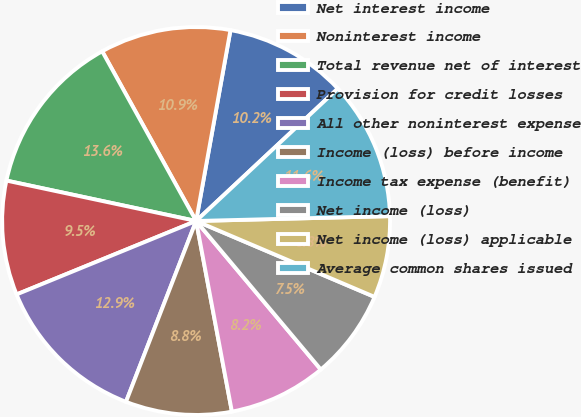Convert chart to OTSL. <chart><loc_0><loc_0><loc_500><loc_500><pie_chart><fcel>Net interest income<fcel>Noninterest income<fcel>Total revenue net of interest<fcel>Provision for credit losses<fcel>All other noninterest expense<fcel>Income (loss) before income<fcel>Income tax expense (benefit)<fcel>Net income (loss)<fcel>Net income (loss) applicable<fcel>Average common shares issued<nl><fcel>10.2%<fcel>10.88%<fcel>13.61%<fcel>9.52%<fcel>12.93%<fcel>8.84%<fcel>8.16%<fcel>7.48%<fcel>6.8%<fcel>11.56%<nl></chart> 